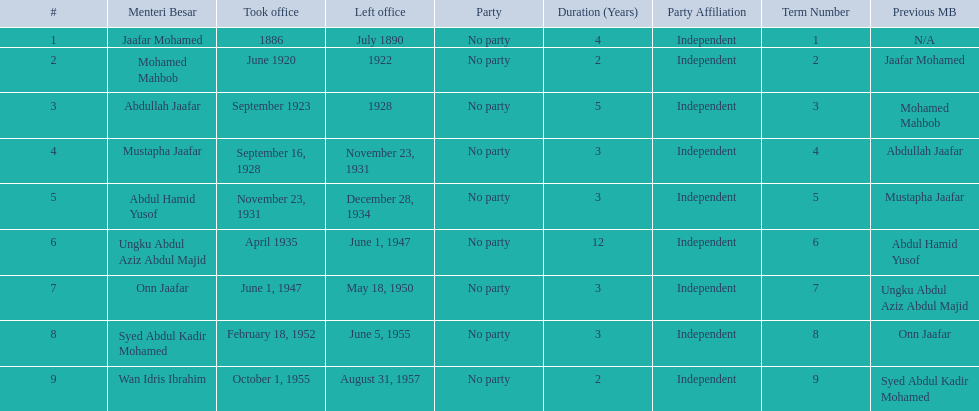When did jaafar mohamed take office? 1886. When did mohamed mahbob take office? June 1920. Who was in office no more than 4 years? Mohamed Mahbob. 